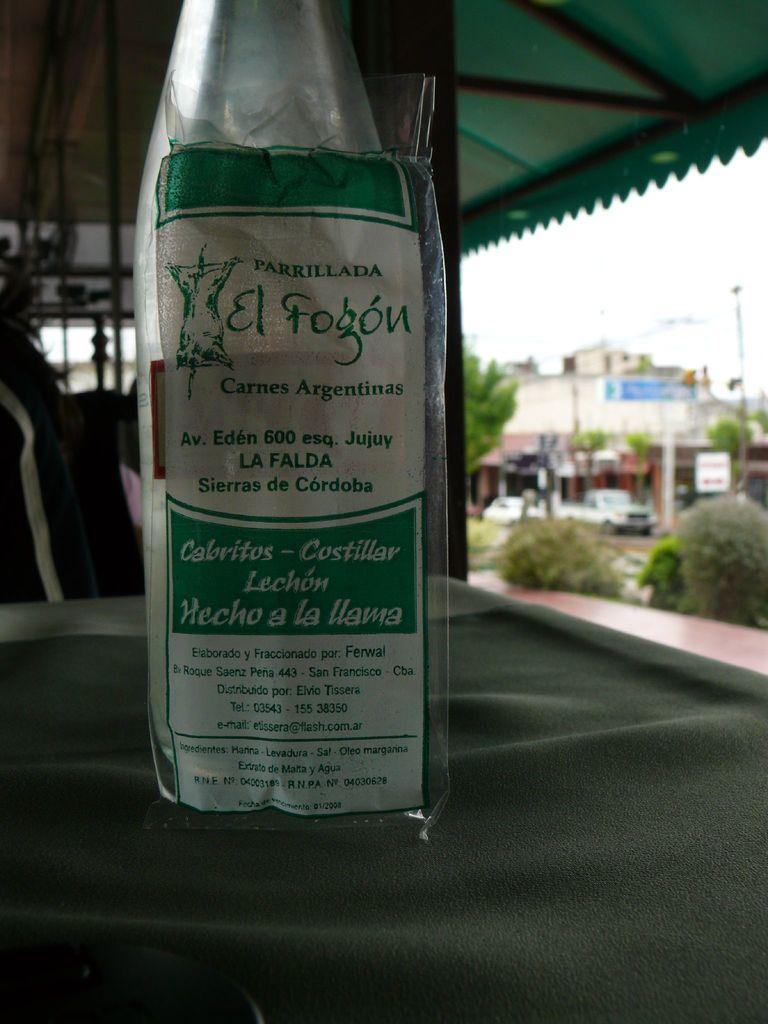Provide a one-sentence caption for the provided image. A bottle with green and white label that reads el fogon. 